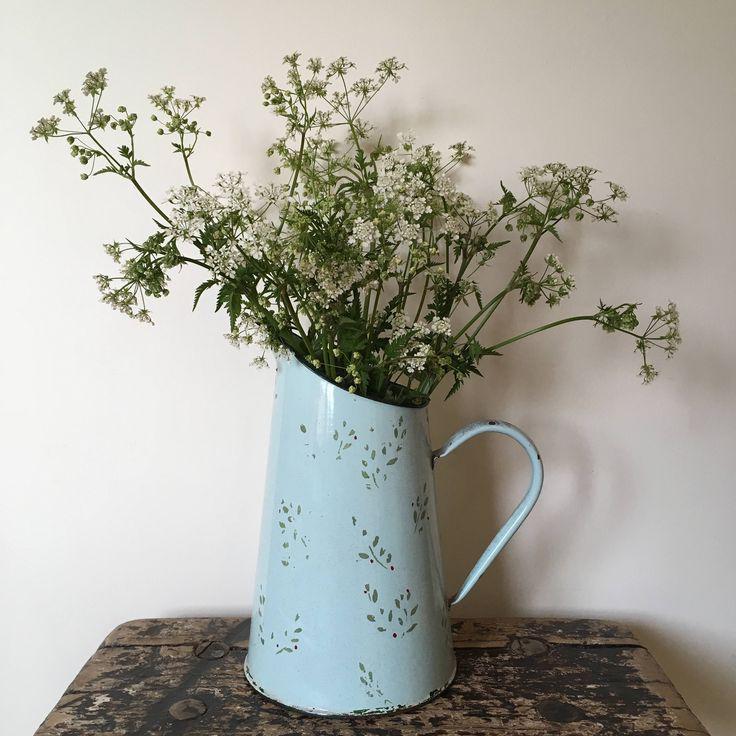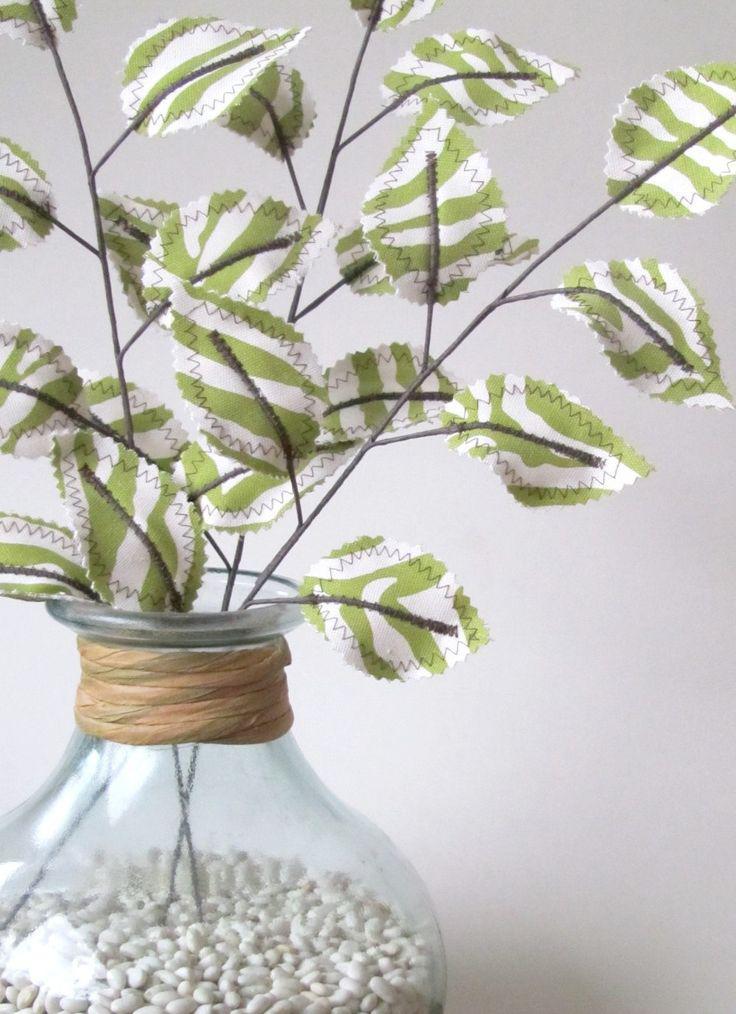The first image is the image on the left, the second image is the image on the right. For the images displayed, is the sentence "there is a vase of flowers sitting in front of a window" factually correct? Answer yes or no. No. 